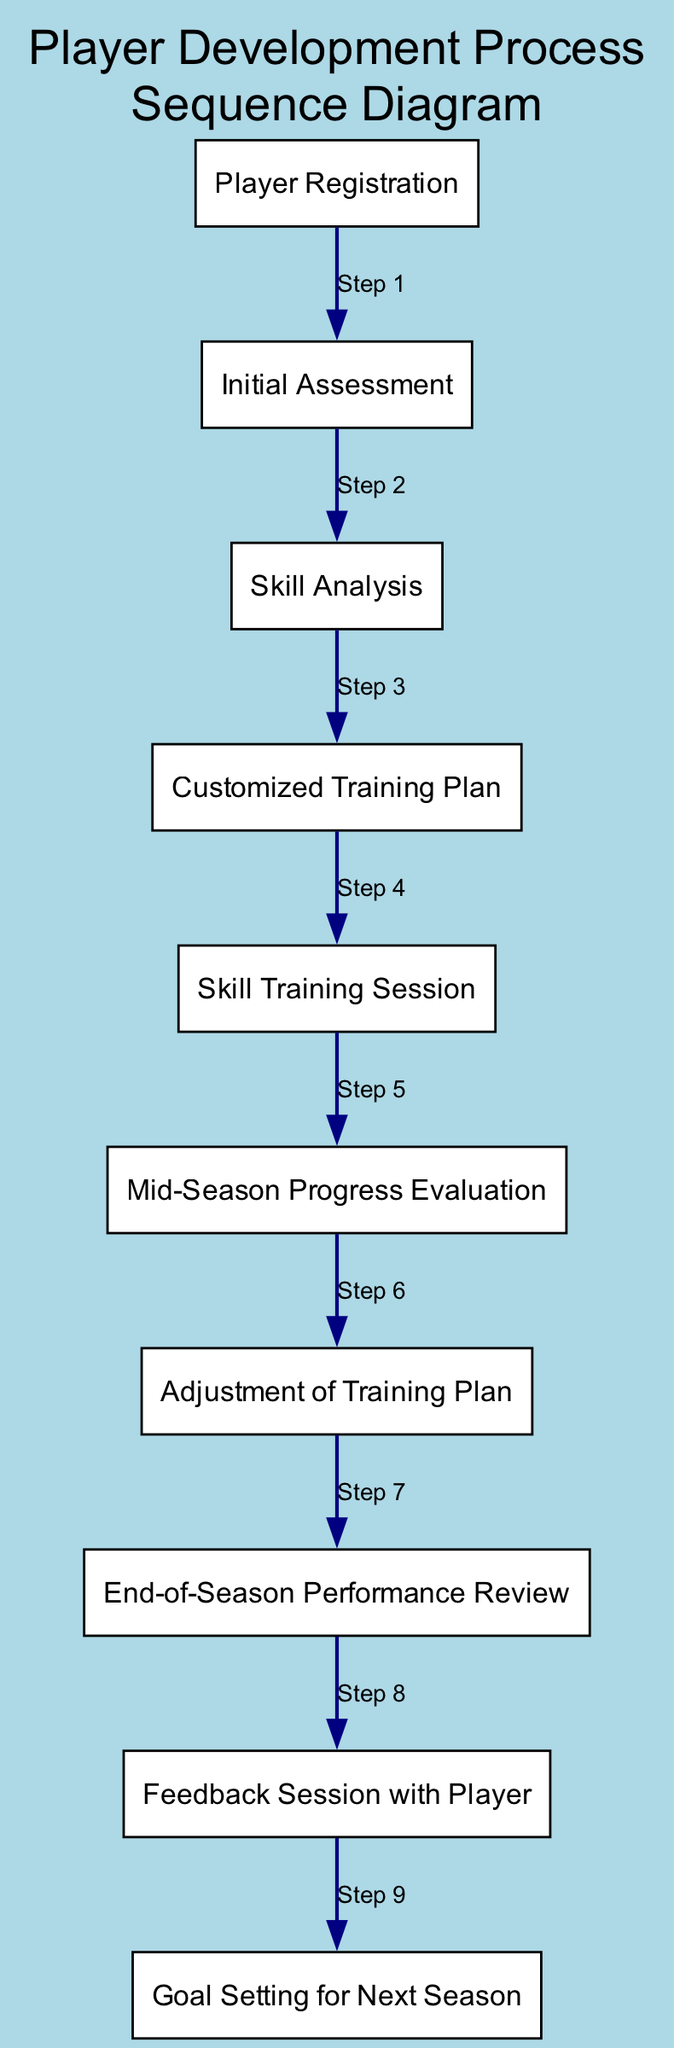What is the first event in the sequence diagram? The sequence diagram starts with the "Player Registration" event, which is the first step outlined in the flow of the process.
Answer: Player Registration How many events are displayed in the diagram? There are a total of ten events listed in the diagram, which include various assessments and evaluations throughout the player development process.
Answer: Ten What event comes after the "Initial Assessment"? The event that follows the "Initial Assessment" in the sequence is "Skill Analysis," as indicated by the flow from one event to the next.
Answer: Skill Analysis What is the last event in the sequence diagram? The last event listed in the sequence diagram is "Goal Setting for Next Season," marking the final step in the player development process.
Answer: Goal Setting for Next Season Which two events are connected directly by an edge in the diagram? The "Feedback Session with Player" is directly connected to the "End-of-Season Performance Review," indicating a sequential flow between these two events in the player development process.
Answer: Feedback Session with Player and End-of-Season Performance Review What is the purpose of the "Mid-Season Progress Evaluation"? The "Mid-Season Progress Evaluation" serves to assess the player's progress at the halfway point of the season to determine if any adjustments to the training plan are necessary.
Answer: Assess progress Which event follows the "Customized Training Plan"? Following the "Customized Training Plan," the next event in the sequence is "Skill Training Session," continuing the process of player development.
Answer: Skill Training Session How many adjustments can be made to the training plan according to the sequence? The diagram indicates that there is one designated step for the "Adjustment of Training Plan," suggesting that adjustments can be made once during the development process.
Answer: One What is the significance of the "End-of-Season Performance Review"? The "End-of-Season Performance Review" is significant as it marks the conclusion of the player development process and evaluates the overall performance of the player throughout the season.
Answer: Overall performance evaluation 